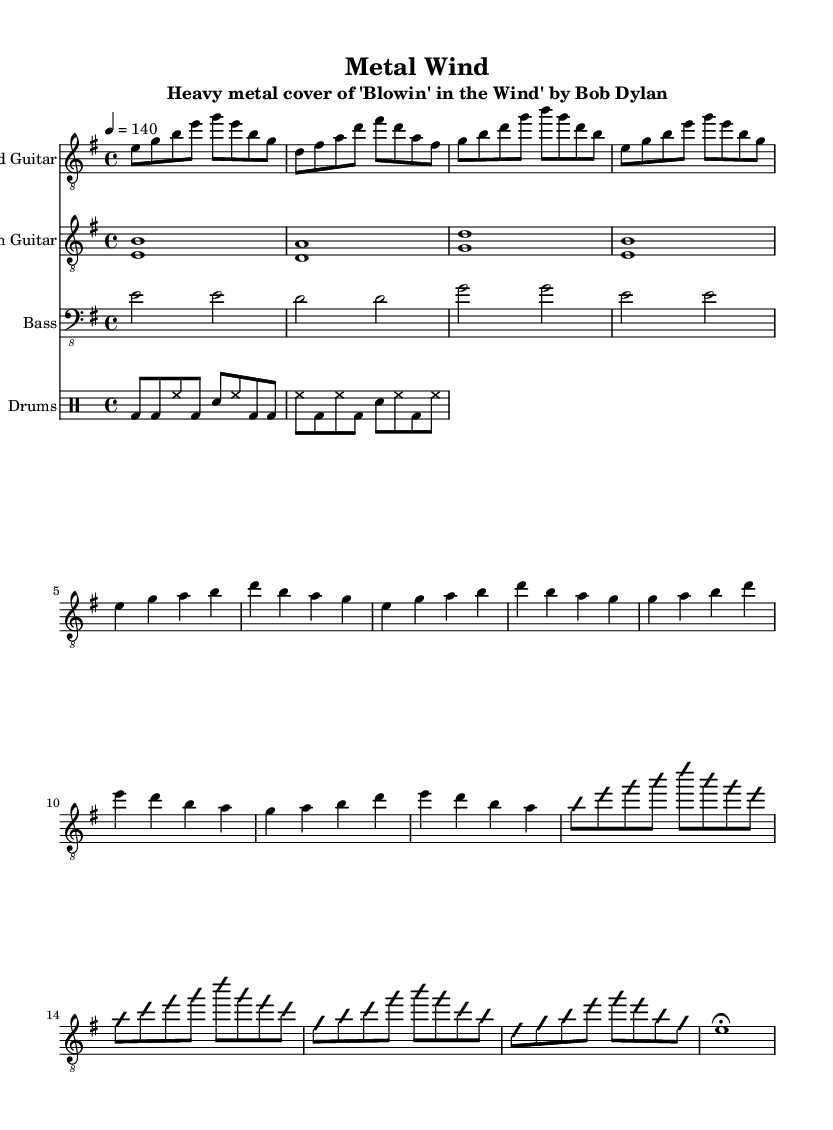What is the key signature of this music? The key signature is E minor, which includes one sharp (F#). This can be determined by looking at the beginning of the sheet music, where the key signature is notated.
Answer: E minor What is the time signature of this piece? The time signature is 4/4. This is indicated right after the key signature at the beginning of the score, showing that there are four beats in each measure.
Answer: 4/4 What is the tempo marking of the piece? The tempo marking is 4 equals 140. This means that there are 140 beats per minute. The tempo is found in the header section of the score.
Answer: 140 How many measures are in the Intro section? The Intro consists of four measures as indicated by the notations, which are divided into groups based on the bar lines in the sheet music.
Answer: 4 measures What type of guitar is featured in this piece? The lead guitar is featured, which plays the main melody and solos as indicated in the score under the "Lead Guitar" staff.
Answer: Lead guitar What drum pattern is primarily used in this piece? The primary drum pattern follows a standard metal beat, which consists of bass drum and snare drum combinations. This pattern can be recognized by the specific drum notation shown in the drum staff.
Answer: Standard metal beat What is the primary function of the rhythm guitar in this song? The rhythm guitar mainly provides power chords to support the harmonic structure and drive the song's energy. This function is clear from the rhythmic nature and duration of the notes in the rhythm guitar staff.
Answer: Provide power chords 